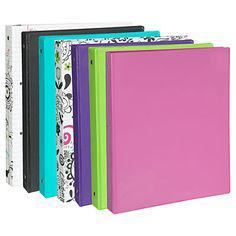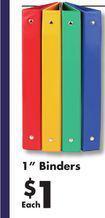The first image is the image on the left, the second image is the image on the right. Considering the images on both sides, is "There are four binders in the image on the right." valid? Answer yes or no. Yes. 